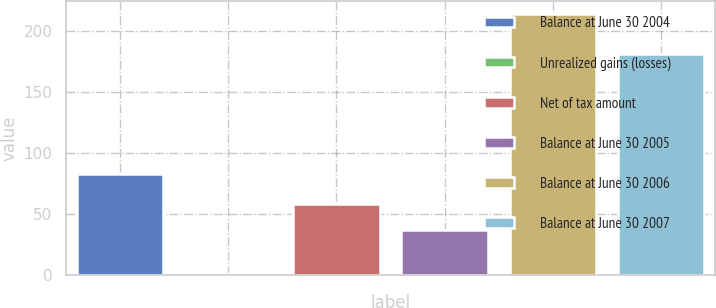Convert chart. <chart><loc_0><loc_0><loc_500><loc_500><bar_chart><fcel>Balance at June 30 2004<fcel>Unrealized gains (losses)<fcel>Net of tax amount<fcel>Balance at June 30 2005<fcel>Balance at June 30 2006<fcel>Balance at June 30 2007<nl><fcel>83<fcel>1<fcel>58.3<fcel>37<fcel>214<fcel>181<nl></chart> 